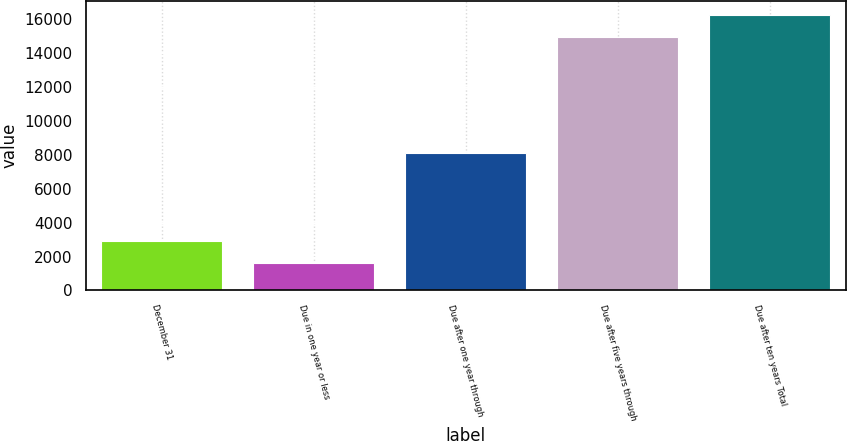Convert chart. <chart><loc_0><loc_0><loc_500><loc_500><bar_chart><fcel>December 31<fcel>Due in one year or less<fcel>Due after one year through<fcel>Due after five years through<fcel>Due after ten years Total<nl><fcel>2934.4<fcel>1595<fcel>8082<fcel>14915<fcel>16254.4<nl></chart> 